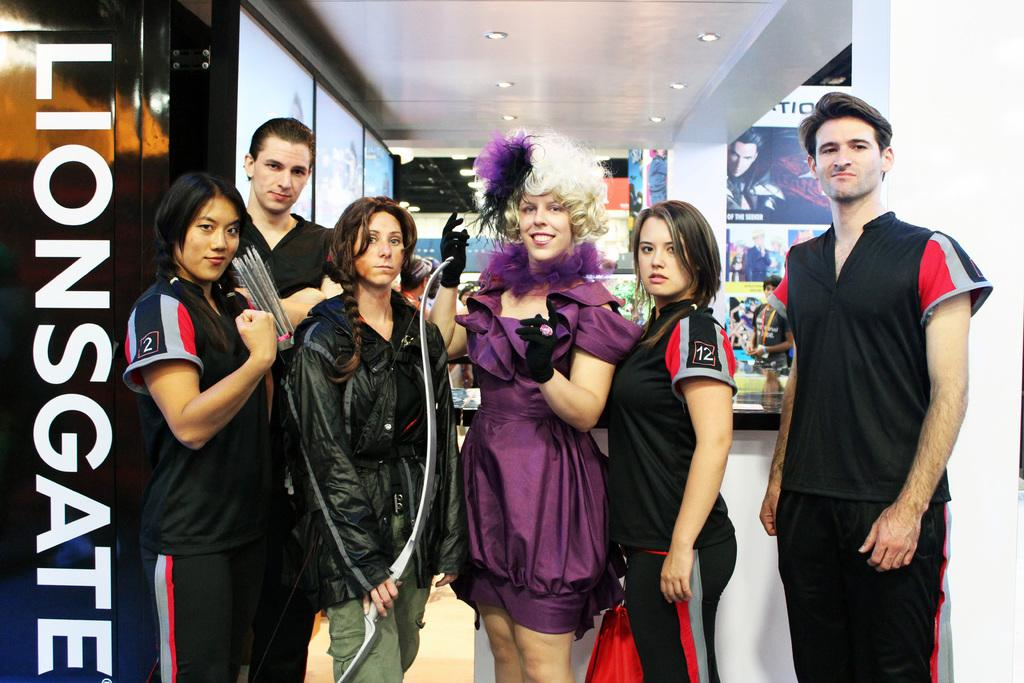<image>
Render a clear and concise summary of the photo. A Lionsgate photo shows six people dressed in odd clothing. 